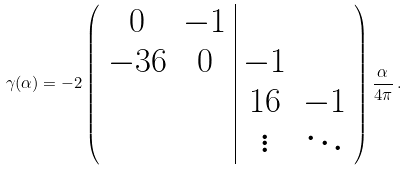Convert formula to latex. <formula><loc_0><loc_0><loc_500><loc_500>\gamma ( \alpha ) = - 2 \left ( \begin{array} { c c | c c } 0 & - 1 \\ - 3 6 & 0 & - 1 \\ & & 1 6 & - 1 \\ & & \vdots & \ddots \end{array} \right ) \frac { \alpha } { 4 \pi } \, .</formula> 